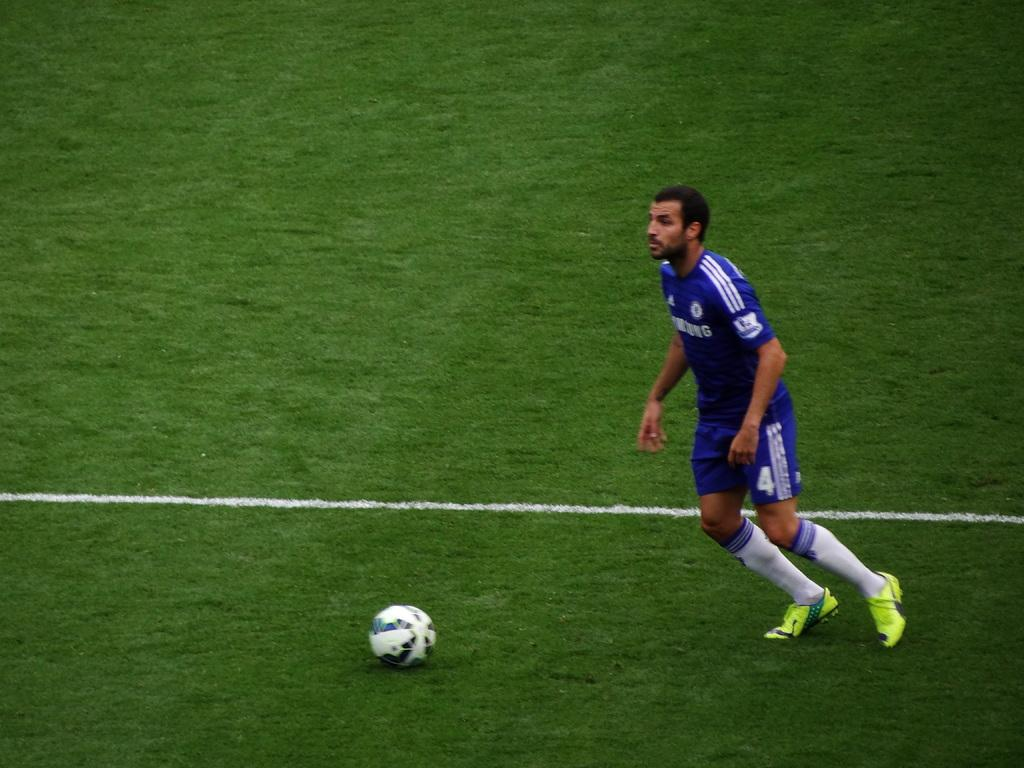<image>
Provide a brief description of the given image. Soccer player number 4 runs towards a soccer ball sitting in the field. 